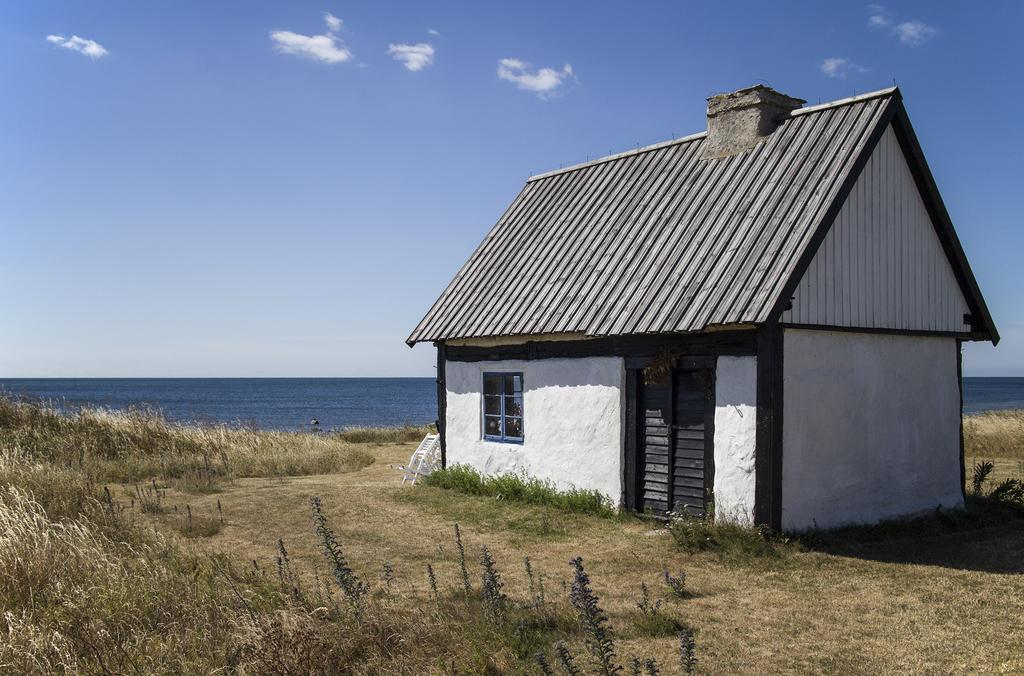What type of structure is present in the image? There is a house in the image. What can be seen in the foreground of the image? There are groups of plants in the foreground. What is visible behind the house? There is water visible behind the house. What is visible at the top of the image? The sky is visible at the top of the image. What type of iron is being used to treat patients in the image? There is no iron or hospital present in the image; it features a house, plants, water, and the sky. 